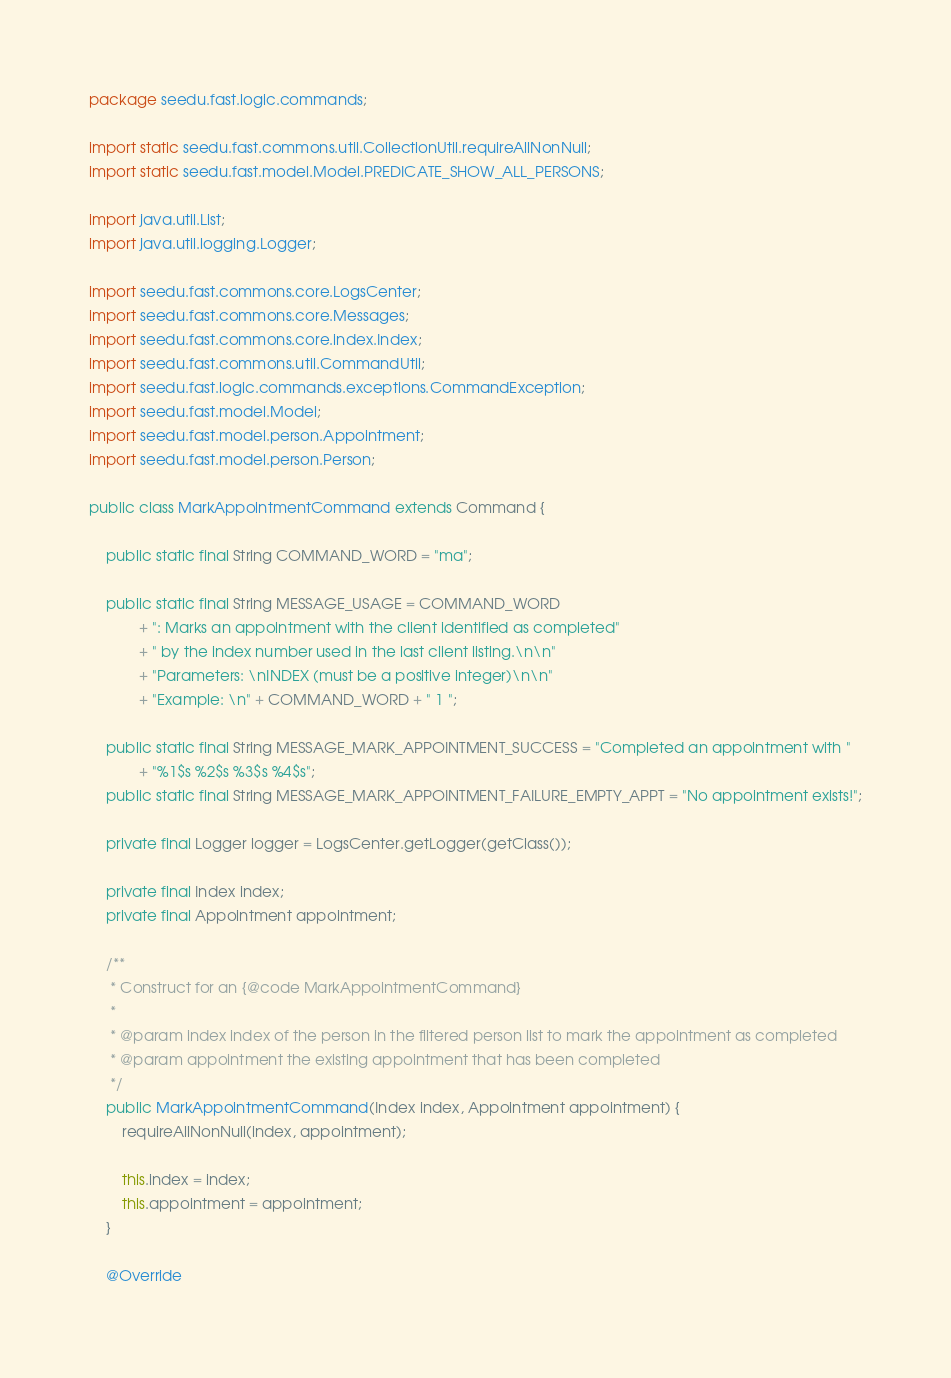Convert code to text. <code><loc_0><loc_0><loc_500><loc_500><_Java_>package seedu.fast.logic.commands;

import static seedu.fast.commons.util.CollectionUtil.requireAllNonNull;
import static seedu.fast.model.Model.PREDICATE_SHOW_ALL_PERSONS;

import java.util.List;
import java.util.logging.Logger;

import seedu.fast.commons.core.LogsCenter;
import seedu.fast.commons.core.Messages;
import seedu.fast.commons.core.index.Index;
import seedu.fast.commons.util.CommandUtil;
import seedu.fast.logic.commands.exceptions.CommandException;
import seedu.fast.model.Model;
import seedu.fast.model.person.Appointment;
import seedu.fast.model.person.Person;

public class MarkAppointmentCommand extends Command {

    public static final String COMMAND_WORD = "ma";

    public static final String MESSAGE_USAGE = COMMAND_WORD
            + ": Marks an appointment with the client identified as completed"
            + " by the index number used in the last client listing.\n\n"
            + "Parameters: \nINDEX (must be a positive integer)\n\n"
            + "Example: \n" + COMMAND_WORD + " 1 ";

    public static final String MESSAGE_MARK_APPOINTMENT_SUCCESS = "Completed an appointment with "
            + "%1$s %2$s %3$s %4$s";
    public static final String MESSAGE_MARK_APPOINTMENT_FAILURE_EMPTY_APPT = "No appointment exists!";

    private final Logger logger = LogsCenter.getLogger(getClass());

    private final Index index;
    private final Appointment appointment;

    /**
     * Construct for an {@code MarkAppointmentCommand}
     *
     * @param index index of the person in the filtered person list to mark the appointment as completed
     * @param appointment the existing appointment that has been completed
     */
    public MarkAppointmentCommand(Index index, Appointment appointment) {
        requireAllNonNull(index, appointment);

        this.index = index;
        this.appointment = appointment;
    }

    @Override</code> 